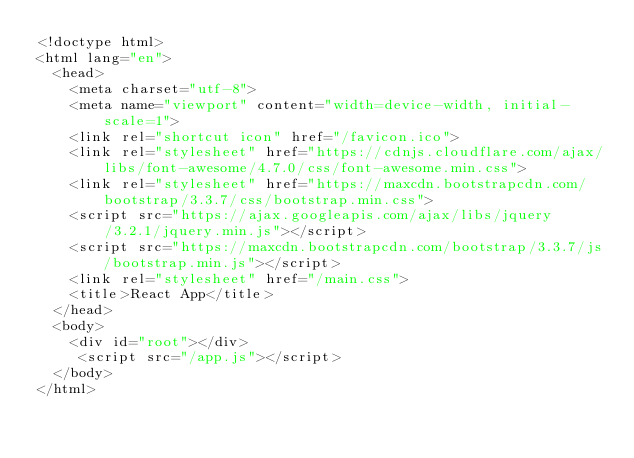<code> <loc_0><loc_0><loc_500><loc_500><_HTML_><!doctype html>
<html lang="en">
  <head>
    <meta charset="utf-8">
    <meta name="viewport" content="width=device-width, initial-scale=1">
    <link rel="shortcut icon" href="/favicon.ico">
    <link rel="stylesheet" href="https://cdnjs.cloudflare.com/ajax/libs/font-awesome/4.7.0/css/font-awesome.min.css">
    <link rel="stylesheet" href="https://maxcdn.bootstrapcdn.com/bootstrap/3.3.7/css/bootstrap.min.css">
    <script src="https://ajax.googleapis.com/ajax/libs/jquery/3.2.1/jquery.min.js"></script>
    <script src="https://maxcdn.bootstrapcdn.com/bootstrap/3.3.7/js/bootstrap.min.js"></script>
    <link rel="stylesheet" href="/main.css">
    <title>React App</title> 
  </head>
  <body>  
    <div id="root"></div>
     <script src="/app.js"></script>
  </body>
</html>
</code> 